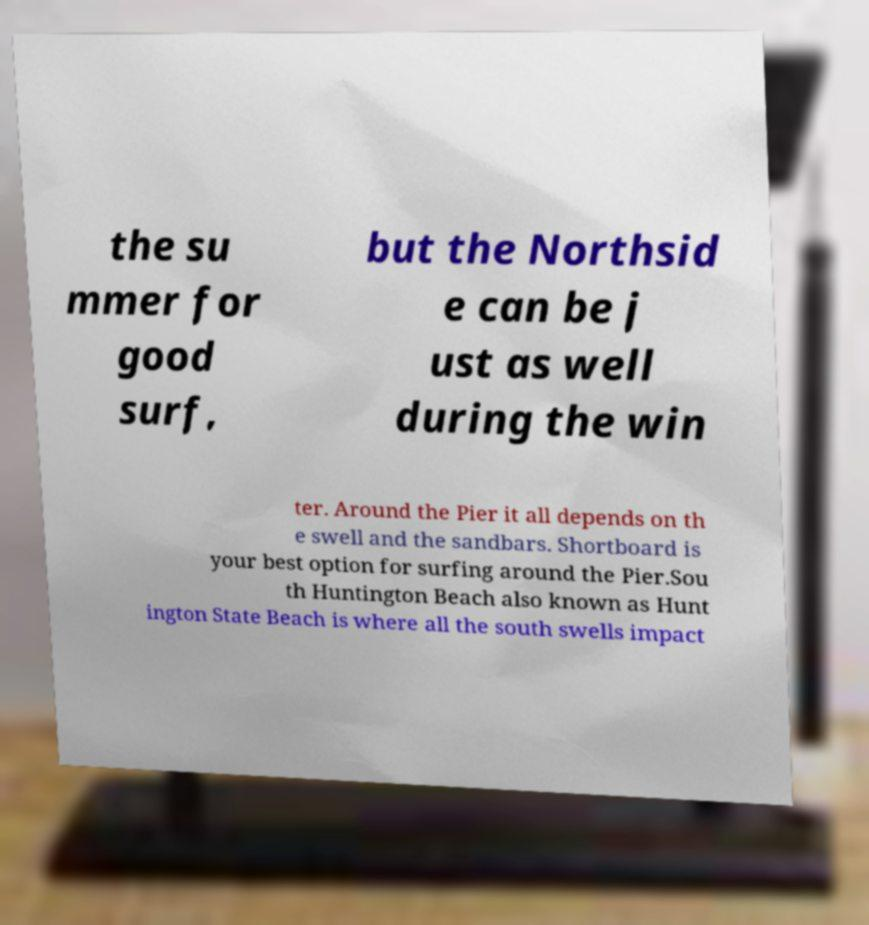Can you accurately transcribe the text from the provided image for me? the su mmer for good surf, but the Northsid e can be j ust as well during the win ter. Around the Pier it all depends on th e swell and the sandbars. Shortboard is your best option for surfing around the Pier.Sou th Huntington Beach also known as Hunt ington State Beach is where all the south swells impact 